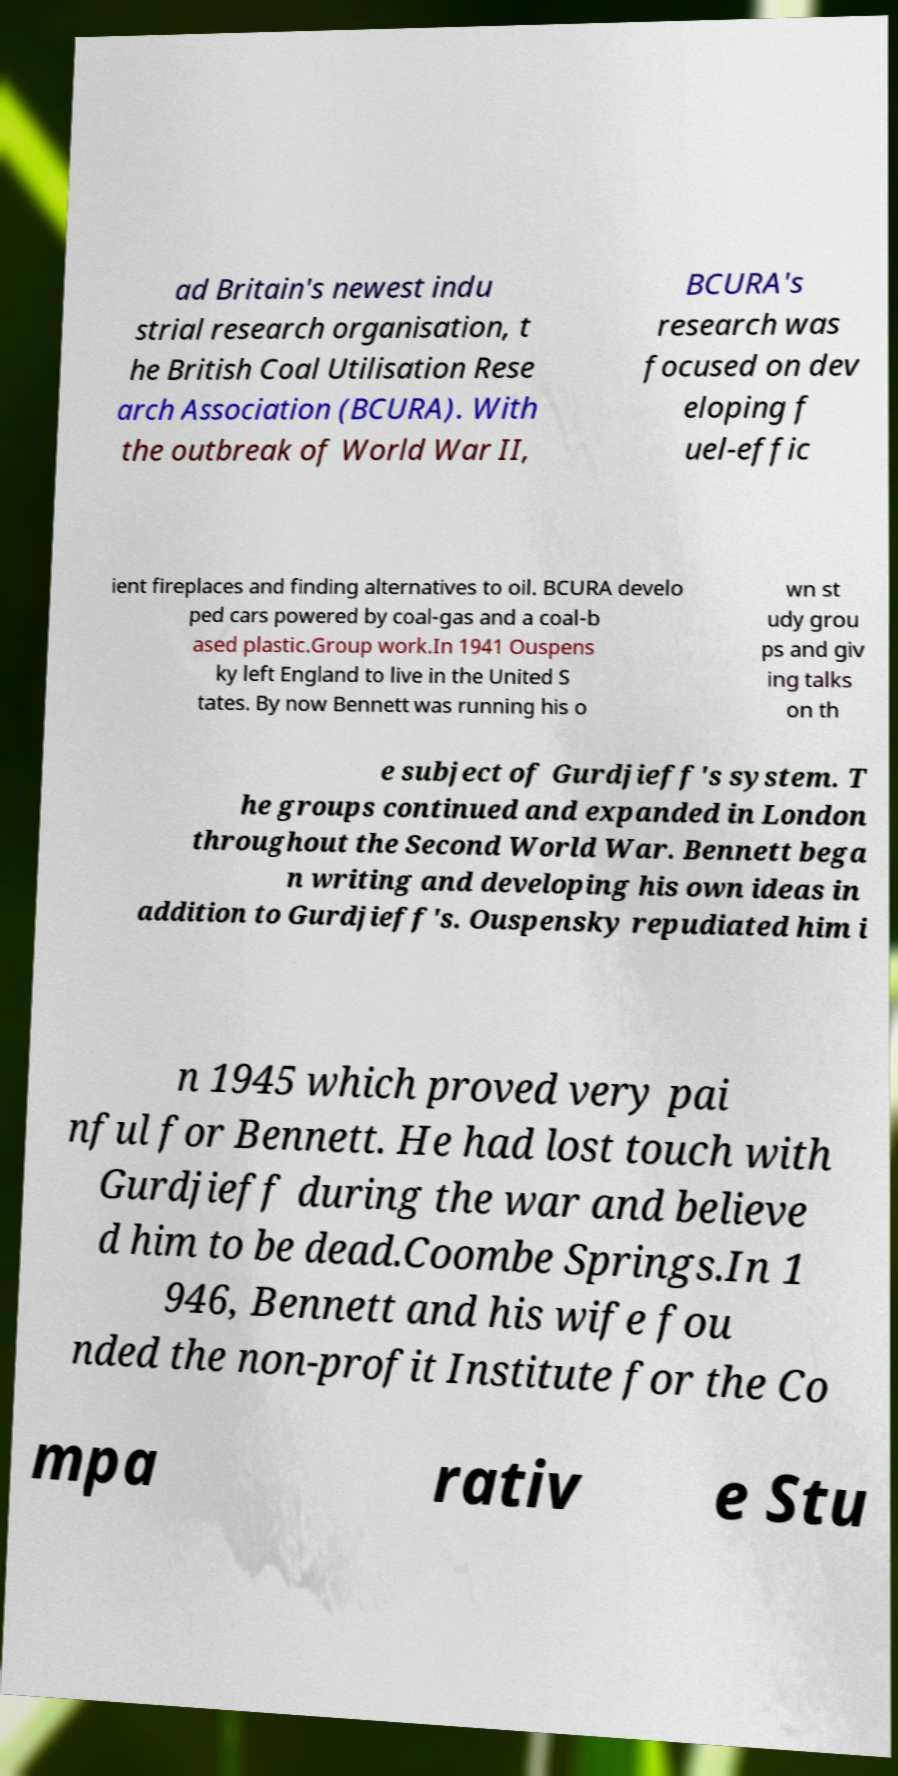Can you accurately transcribe the text from the provided image for me? ad Britain's newest indu strial research organisation, t he British Coal Utilisation Rese arch Association (BCURA). With the outbreak of World War II, BCURA's research was focused on dev eloping f uel-effic ient fireplaces and finding alternatives to oil. BCURA develo ped cars powered by coal-gas and a coal-b ased plastic.Group work.In 1941 Ouspens ky left England to live in the United S tates. By now Bennett was running his o wn st udy grou ps and giv ing talks on th e subject of Gurdjieff's system. T he groups continued and expanded in London throughout the Second World War. Bennett bega n writing and developing his own ideas in addition to Gurdjieff's. Ouspensky repudiated him i n 1945 which proved very pai nful for Bennett. He had lost touch with Gurdjieff during the war and believe d him to be dead.Coombe Springs.In 1 946, Bennett and his wife fou nded the non-profit Institute for the Co mpa rativ e Stu 